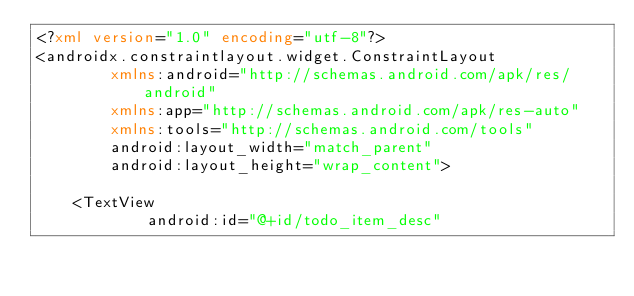<code> <loc_0><loc_0><loc_500><loc_500><_XML_><?xml version="1.0" encoding="utf-8"?>
<androidx.constraintlayout.widget.ConstraintLayout
        xmlns:android="http://schemas.android.com/apk/res/android"
        xmlns:app="http://schemas.android.com/apk/res-auto"
        xmlns:tools="http://schemas.android.com/tools"
        android:layout_width="match_parent"
        android:layout_height="wrap_content">

    <TextView
            android:id="@+id/todo_item_desc"</code> 